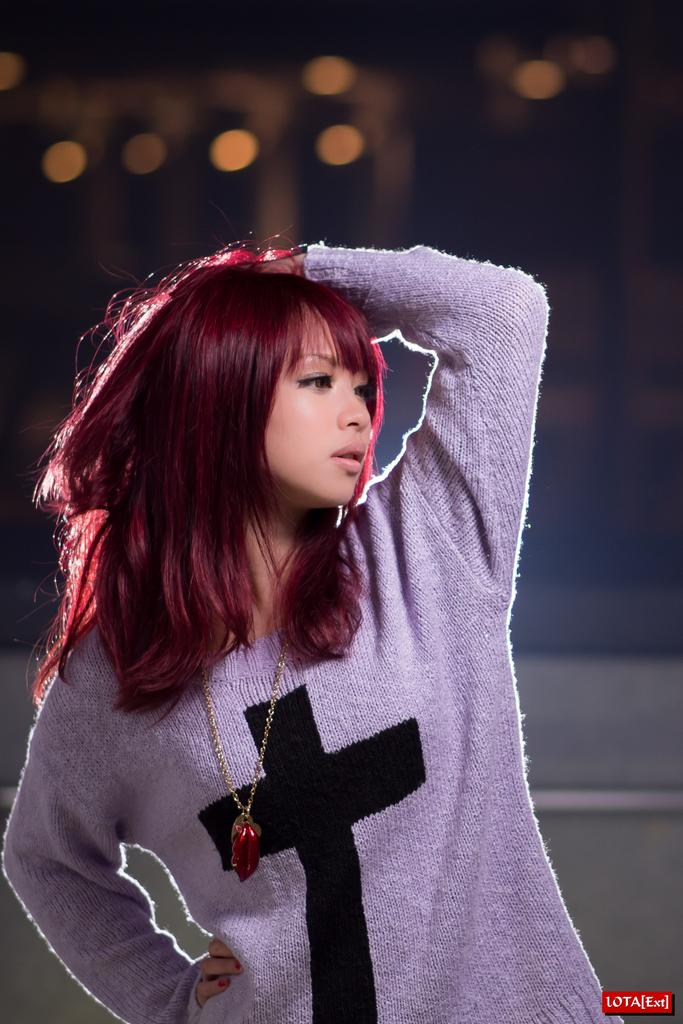Who is present in the image? There is a woman in the image. What is the woman wearing in the image? The woman is wearing a chain in the image. What can be found at the bottom of the image? There is text at the bottom of the image. What can be seen in the background of the image? There are lights visible in the background of the image. How many snails can be seen crawling on the woman's chain in the image? There are no snails present in the image, and therefore none can be seen crawling on the woman's chain. 